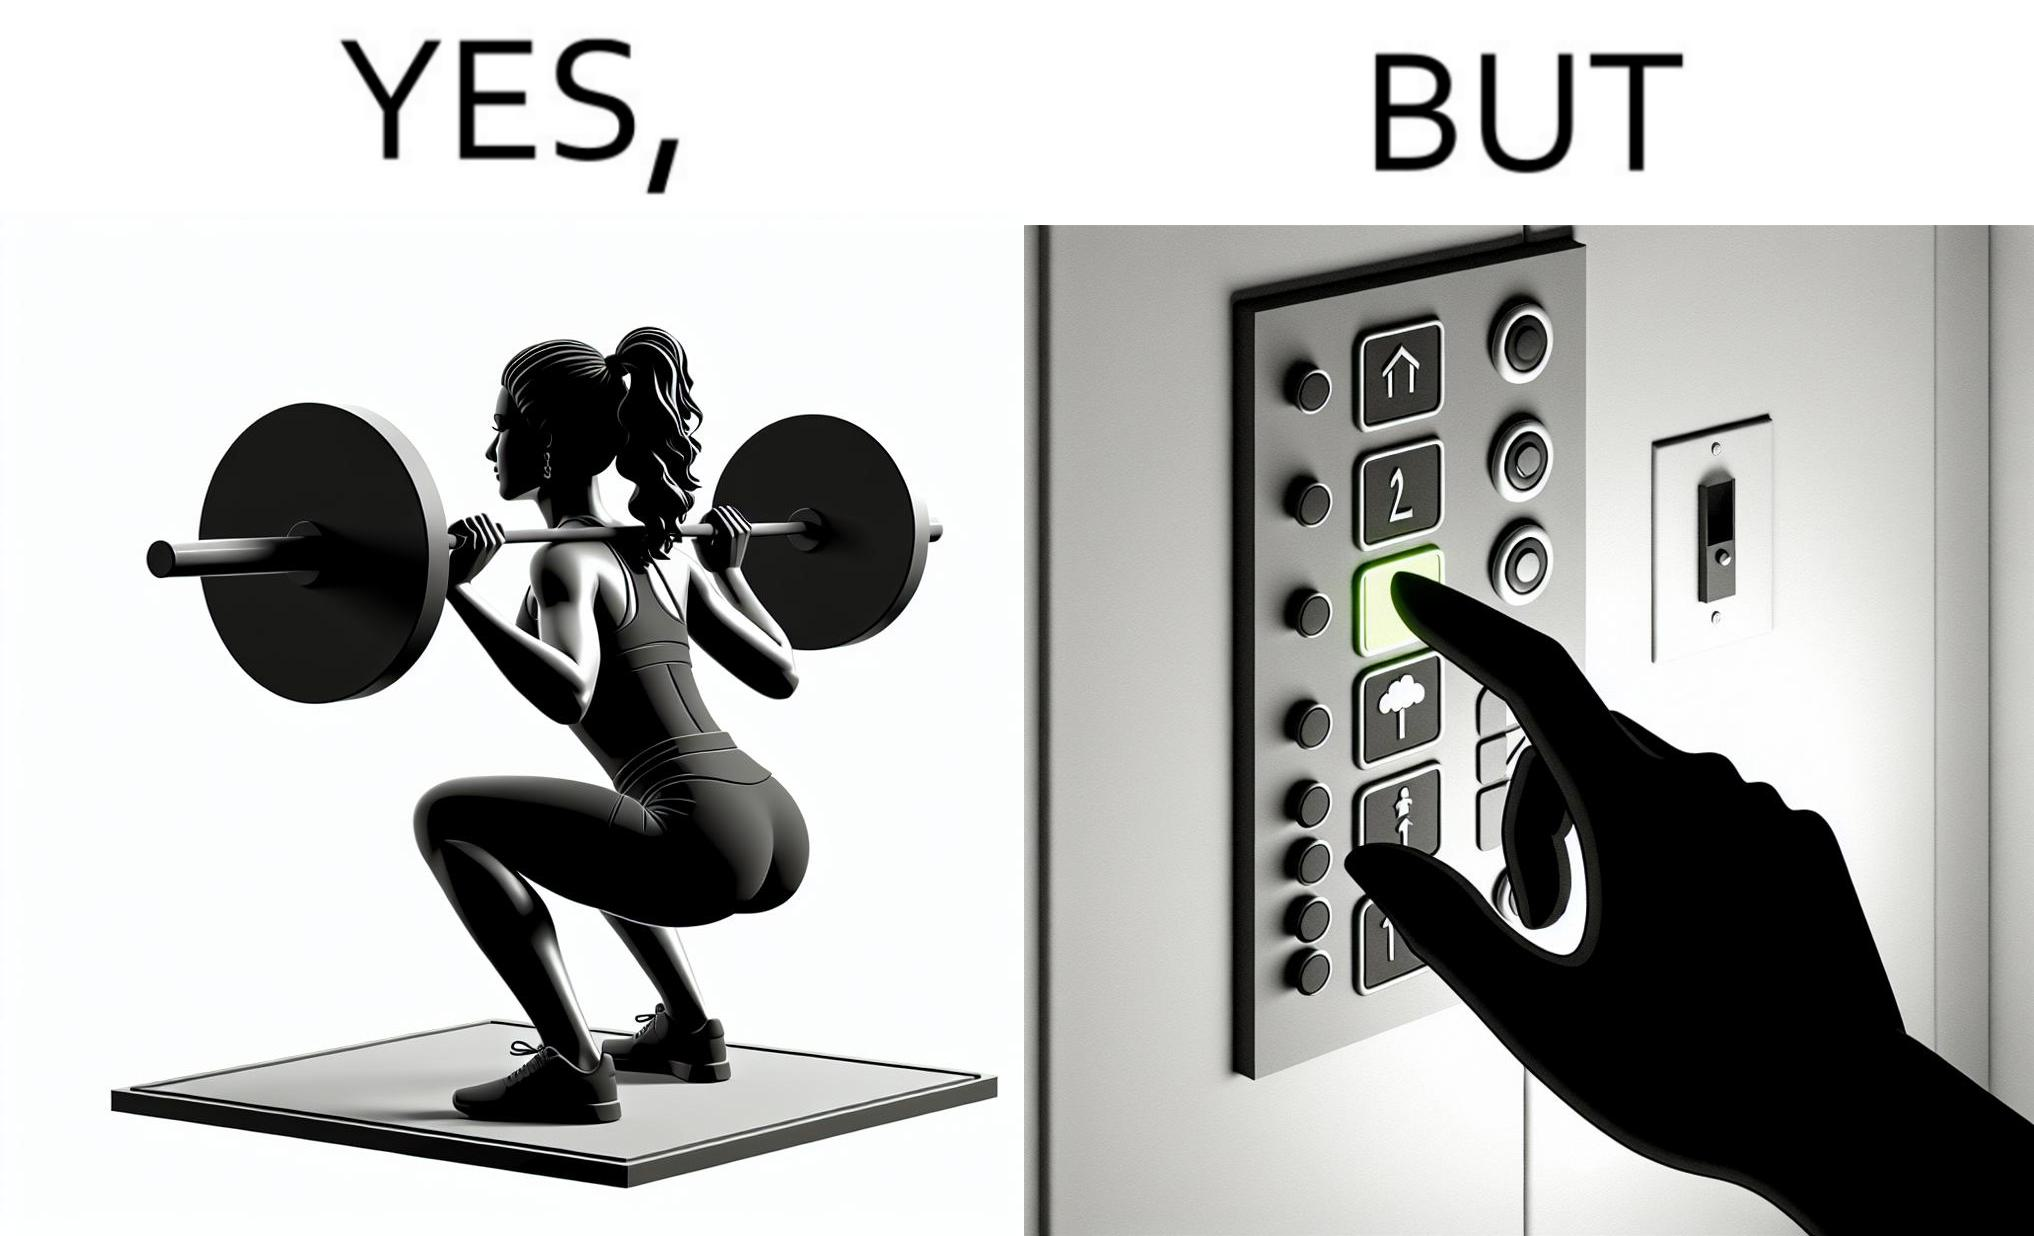Would you classify this image as satirical? Yes, this image is satirical. 